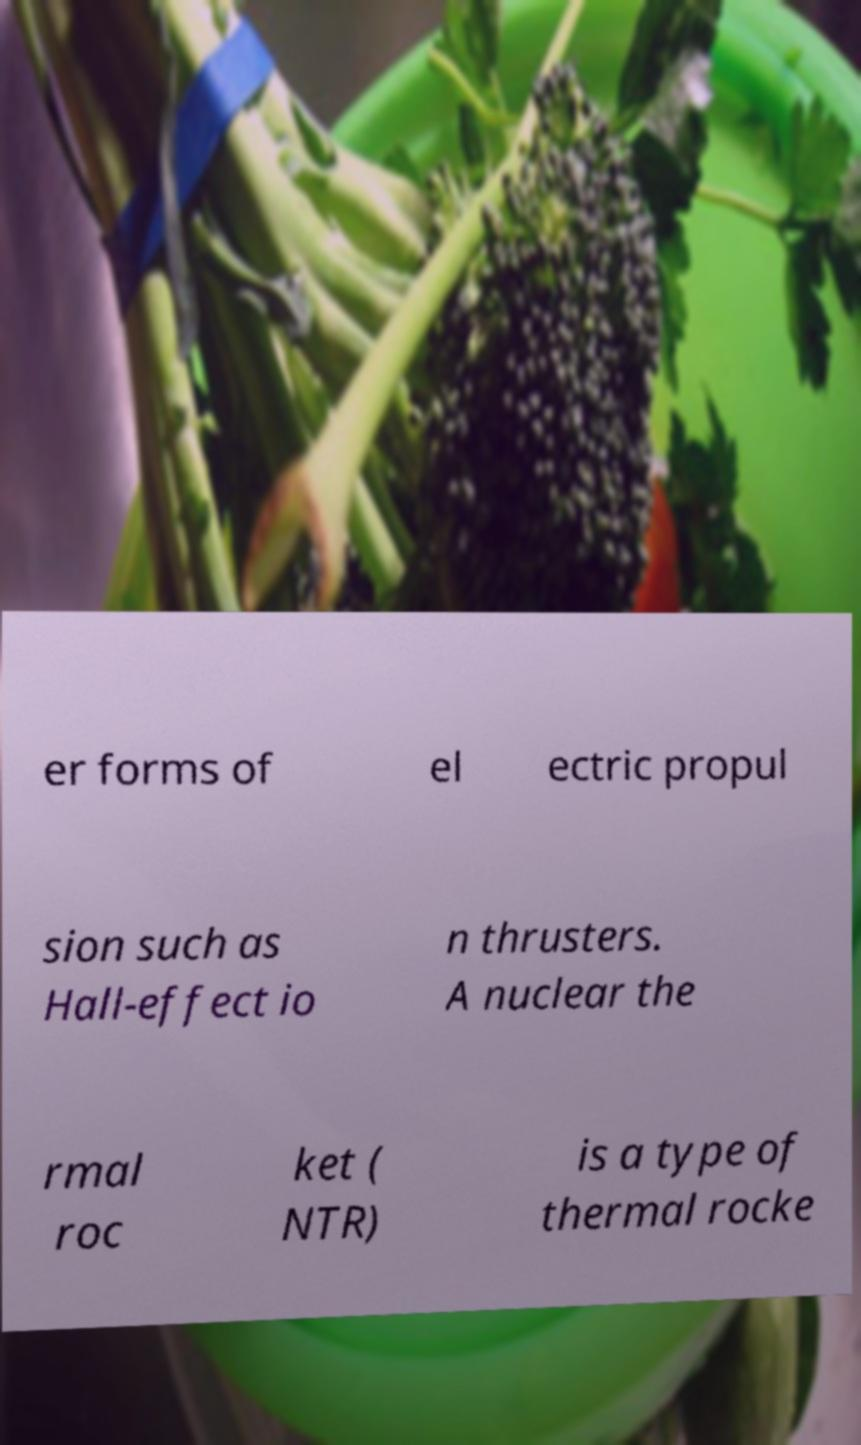Could you extract and type out the text from this image? er forms of el ectric propul sion such as Hall-effect io n thrusters. A nuclear the rmal roc ket ( NTR) is a type of thermal rocke 